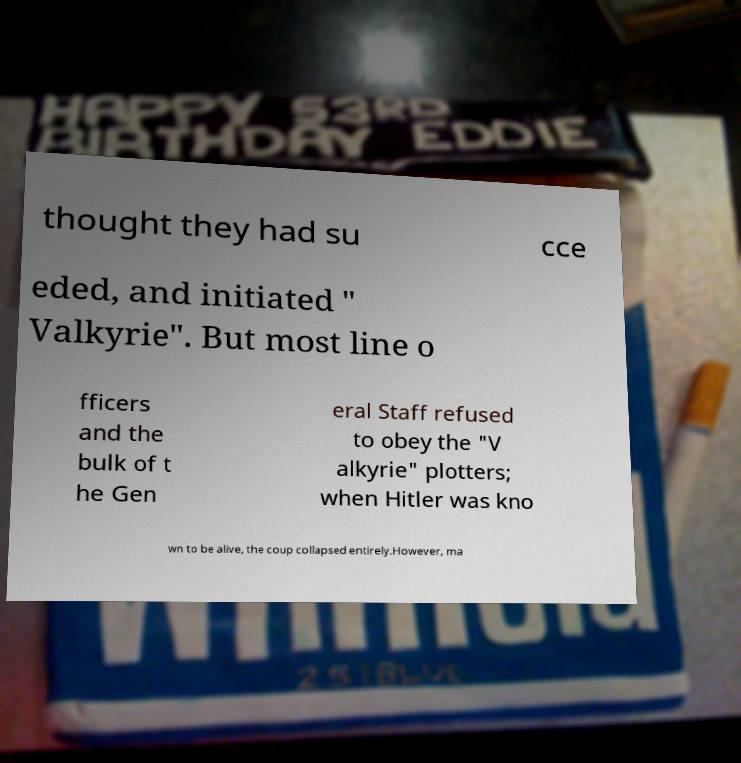Can you accurately transcribe the text from the provided image for me? thought they had su cce eded, and initiated " Valkyrie". But most line o fficers and the bulk of t he Gen eral Staff refused to obey the "V alkyrie" plotters; when Hitler was kno wn to be alive, the coup collapsed entirely.However, ma 